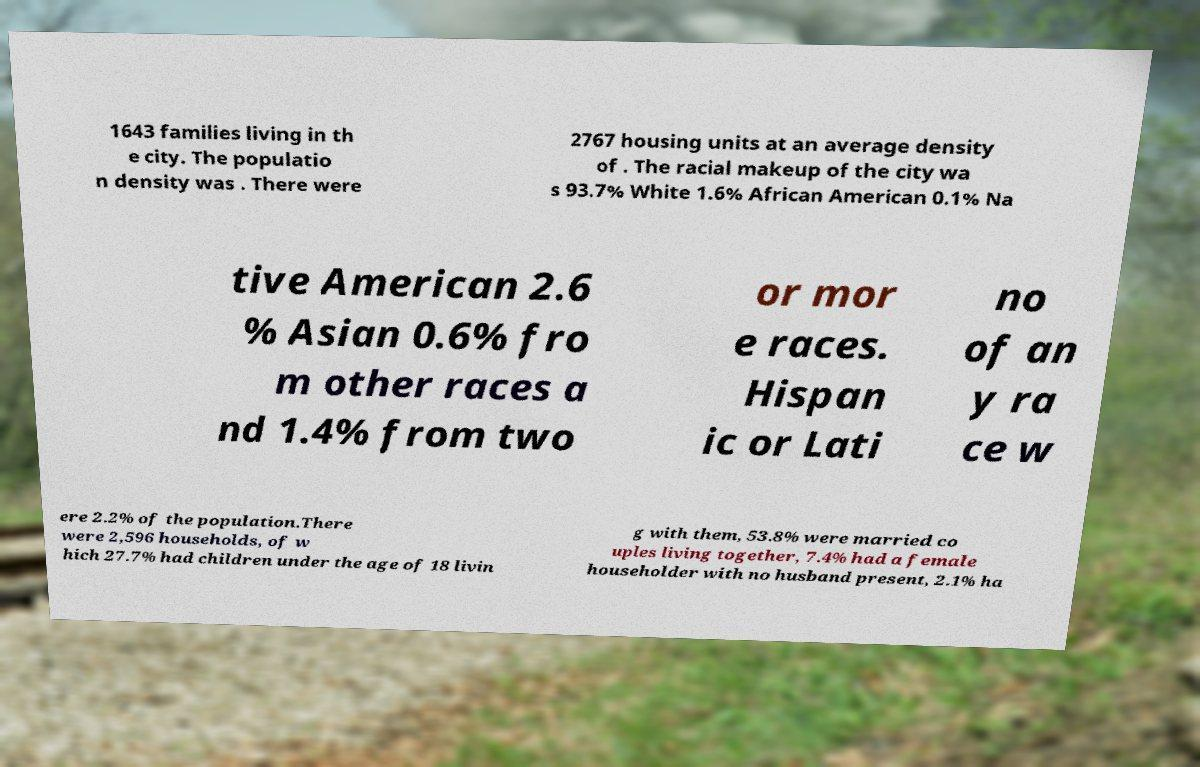For documentation purposes, I need the text within this image transcribed. Could you provide that? 1643 families living in th e city. The populatio n density was . There were 2767 housing units at an average density of . The racial makeup of the city wa s 93.7% White 1.6% African American 0.1% Na tive American 2.6 % Asian 0.6% fro m other races a nd 1.4% from two or mor e races. Hispan ic or Lati no of an y ra ce w ere 2.2% of the population.There were 2,596 households, of w hich 27.7% had children under the age of 18 livin g with them, 53.8% were married co uples living together, 7.4% had a female householder with no husband present, 2.1% ha 